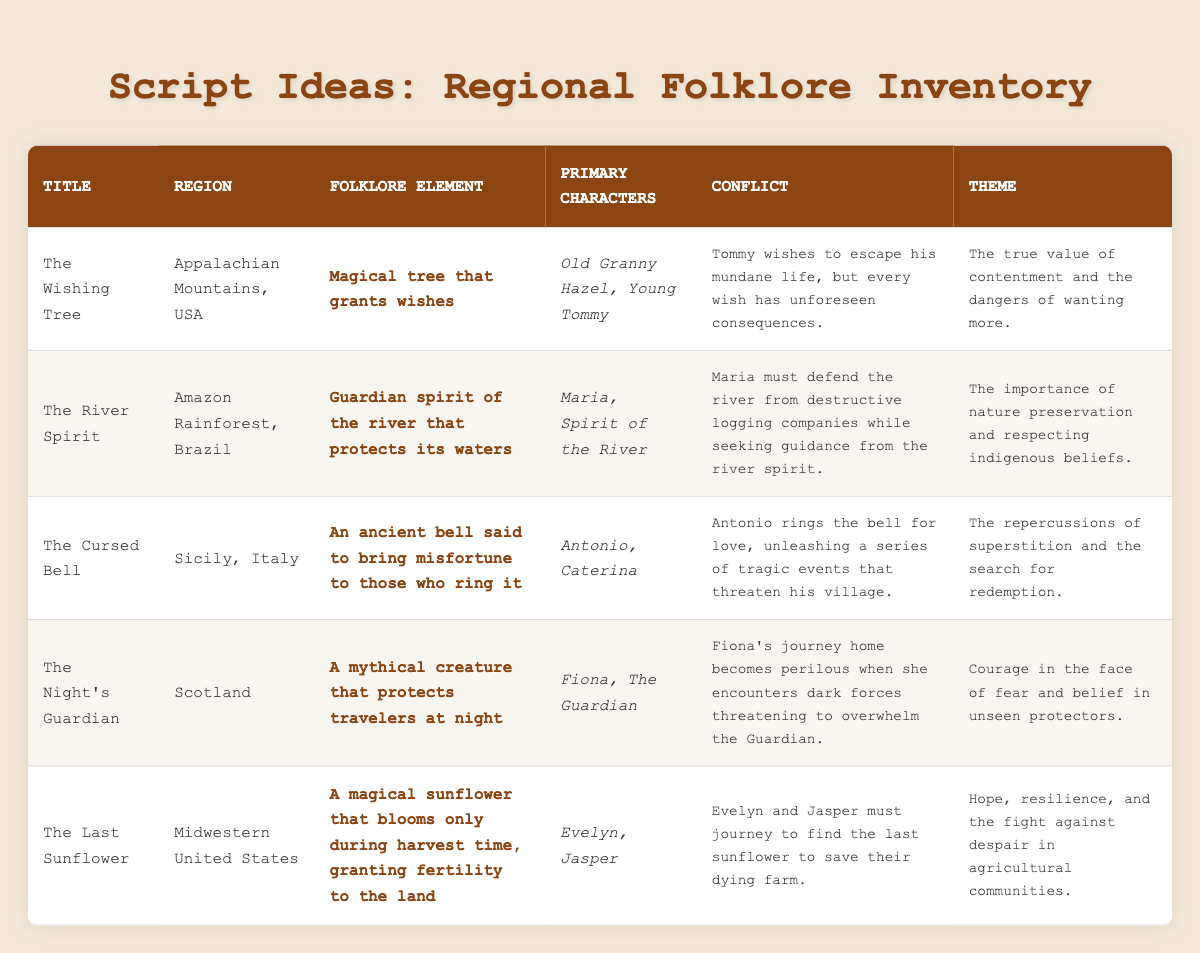What is the title of the script idea set in the Appalachian Mountains? The table states that the title of the script idea corresponding to the Appalachian Mountains is "The Wishing Tree."
Answer: The Wishing Tree Which region features a story about a guardian spirit of the river? According to the table, the region featuring a story about a guardian spirit of the river is the Amazon Rainforest in Brazil, with the script titled "The River Spirit."
Answer: Amazon Rainforest, Brazil Do any of the script ideas have a theme related to nature preservation? The table displays "The River Spirit" as one of the script ideas, which prominently features the theme of the importance of nature preservation and respecting indigenous beliefs.
Answer: Yes How many primary characters are in "The Cursed Bell"? From the table, "The Cursed Bell" has two primary characters listed: Antonio and Caterina.
Answer: Two What are the contrasting themes present in "The Wishing Tree" and "The Night's Guardian"? The themes of "The Wishing Tree" focus on the true value of contentment and wanting more, while "The Night's Guardian" revolves around courage in the face of fear and belief in unseen protectors. This indicates a contrast between inner peace and external challenges.
Answer: Contrast of contentment vs. courage In "The Last Sunflower," what conflict do the characters face? The table indicates that the conflict in "The Last Sunflower" is that Evelyn and Jasper must journey to find the last sunflower in order to save their dying farm.
Answer: Journey to find a sunflower to save the farm Which script features a theme surrounding superstition and redemption? The table specifies that "The Cursed Bell" features the theme of the repercussions of superstition and the search for redemption.
Answer: The Cursed Bell Which regions have stories involving young characters? In the table, "The Wishing Tree" involves a young character named Tommy, and "The Last Sunflower" features Jasper as a character, indicating that Appalachian Mountains and Midwestern United States both contain stories with young characters.
Answer: Appalachian Mountains and Midwestern United States What is the common element that links "The River Spirit" and "The Last Sunflower"? Both "The River Spirit" and "The Last Sunflower" emphasize themes of nature and preservation; "The River Spirit" speaks to protecting the river, while "The Last Sunflower" highlights fertility granted by the sunflower, crucial for the farm.
Answer: Nature and preservation themes 